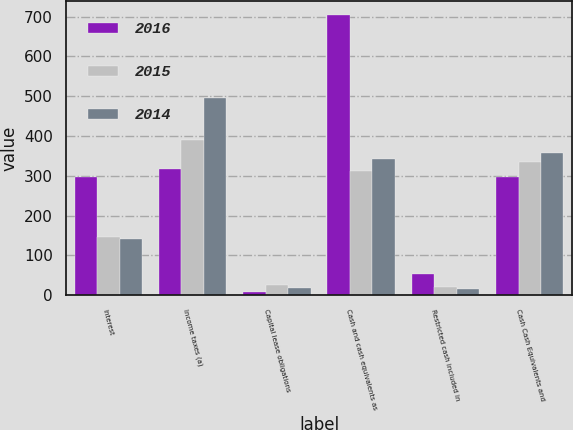<chart> <loc_0><loc_0><loc_500><loc_500><stacked_bar_chart><ecel><fcel>Interest<fcel>Income taxes (a)<fcel>Capital lease obligations<fcel>Cash and cash equivalents as<fcel>Restricted cash included in<fcel>Cash Cash Equivalents and<nl><fcel>2016<fcel>297<fcel>317<fcel>9<fcel>704<fcel>53<fcel>297<nl><fcel>2015<fcel>145<fcel>390<fcel>25<fcel>313<fcel>21<fcel>334<nl><fcel>2014<fcel>141<fcel>495<fcel>17<fcel>341<fcel>16<fcel>357<nl></chart> 